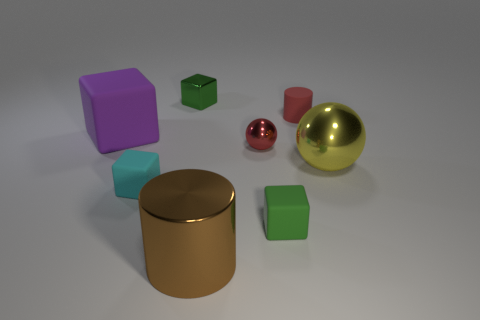What number of objects are either metallic things in front of the yellow metal object or green things that are in front of the yellow ball?
Your answer should be compact. 2. What is the shape of the small thing that is the same color as the small metal ball?
Provide a succinct answer. Cylinder. There is a big metal object that is left of the yellow metallic sphere; what is its shape?
Offer a terse response. Cylinder. There is a large shiny thing in front of the large yellow thing; is its shape the same as the tiny cyan rubber thing?
Offer a terse response. No. What number of objects are either green blocks behind the small green rubber object or big brown metallic cylinders?
Give a very brief answer. 2. There is another big object that is the same shape as the cyan matte object; what is its color?
Keep it short and to the point. Purple. Is there any other thing of the same color as the small cylinder?
Give a very brief answer. Yes. How big is the green object that is on the right side of the green metal cube?
Offer a very short reply. Small. There is a tiny metal ball; does it have the same color as the big shiny cylinder that is in front of the shiny block?
Your answer should be compact. No. How many other objects are there of the same material as the big ball?
Your answer should be very brief. 3. 